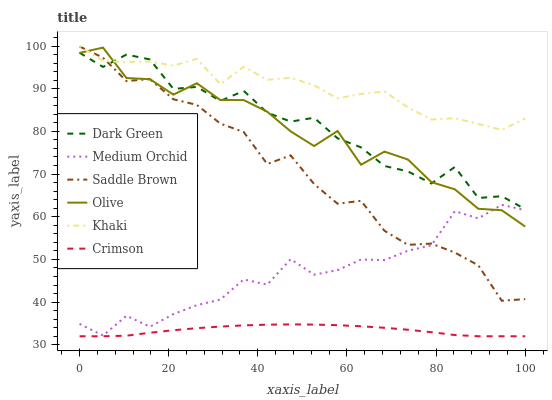Does Medium Orchid have the minimum area under the curve?
Answer yes or no. No. Does Medium Orchid have the maximum area under the curve?
Answer yes or no. No. Is Medium Orchid the smoothest?
Answer yes or no. No. Is Medium Orchid the roughest?
Answer yes or no. No. Does Medium Orchid have the lowest value?
Answer yes or no. No. Does Medium Orchid have the highest value?
Answer yes or no. No. Is Medium Orchid less than Dark Green?
Answer yes or no. Yes. Is Khaki greater than Crimson?
Answer yes or no. Yes. Does Medium Orchid intersect Dark Green?
Answer yes or no. No. 